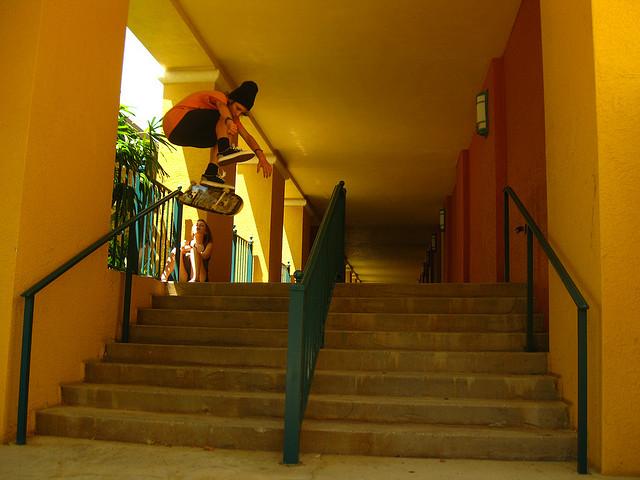Is the skater alone?
Short answer required. No. Why is he coming down the stairs?
Short answer required. Skateboarding. What are the stair rails made of?
Quick response, please. Metal. Has the boy taken all safety precautions before playing?
Quick response, please. No. 